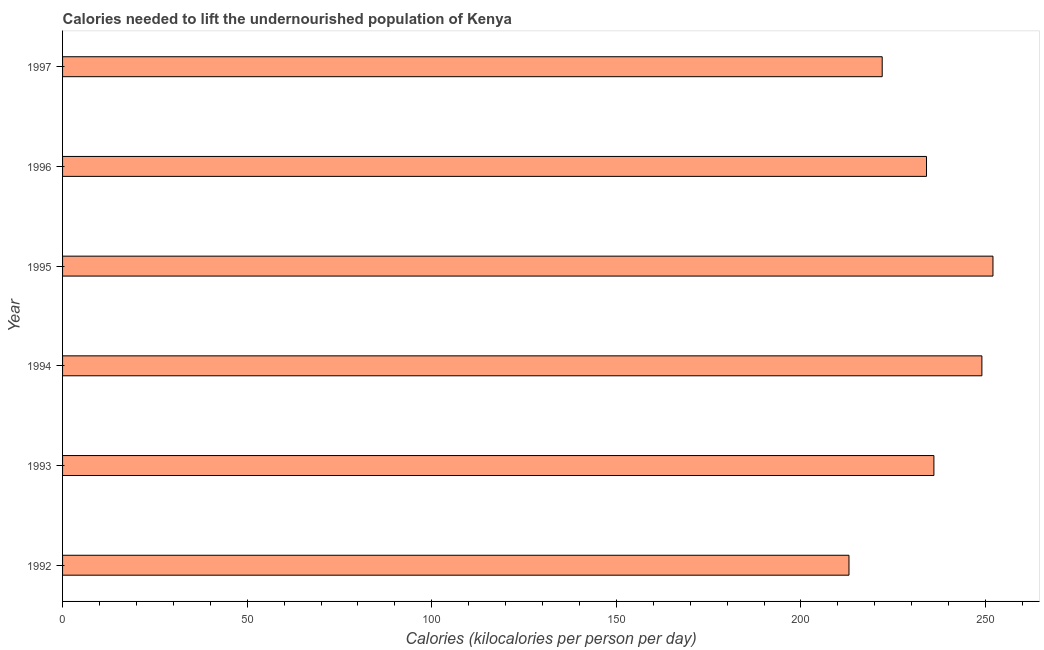Does the graph contain grids?
Provide a succinct answer. No. What is the title of the graph?
Keep it short and to the point. Calories needed to lift the undernourished population of Kenya. What is the label or title of the X-axis?
Keep it short and to the point. Calories (kilocalories per person per day). What is the depth of food deficit in 1996?
Your response must be concise. 234. Across all years, what is the maximum depth of food deficit?
Provide a short and direct response. 252. Across all years, what is the minimum depth of food deficit?
Your response must be concise. 213. In which year was the depth of food deficit minimum?
Make the answer very short. 1992. What is the sum of the depth of food deficit?
Your answer should be compact. 1406. What is the difference between the depth of food deficit in 1996 and 1997?
Provide a short and direct response. 12. What is the average depth of food deficit per year?
Your answer should be compact. 234. What is the median depth of food deficit?
Keep it short and to the point. 235. In how many years, is the depth of food deficit greater than 150 kilocalories?
Offer a terse response. 6. What is the ratio of the depth of food deficit in 1993 to that in 1994?
Your response must be concise. 0.95. What is the difference between the highest and the second highest depth of food deficit?
Make the answer very short. 3. Is the sum of the depth of food deficit in 1994 and 1997 greater than the maximum depth of food deficit across all years?
Offer a terse response. Yes. In how many years, is the depth of food deficit greater than the average depth of food deficit taken over all years?
Your response must be concise. 3. Are all the bars in the graph horizontal?
Keep it short and to the point. Yes. Are the values on the major ticks of X-axis written in scientific E-notation?
Make the answer very short. No. What is the Calories (kilocalories per person per day) of 1992?
Give a very brief answer. 213. What is the Calories (kilocalories per person per day) in 1993?
Make the answer very short. 236. What is the Calories (kilocalories per person per day) in 1994?
Ensure brevity in your answer.  249. What is the Calories (kilocalories per person per day) of 1995?
Keep it short and to the point. 252. What is the Calories (kilocalories per person per day) in 1996?
Keep it short and to the point. 234. What is the Calories (kilocalories per person per day) in 1997?
Give a very brief answer. 222. What is the difference between the Calories (kilocalories per person per day) in 1992 and 1993?
Make the answer very short. -23. What is the difference between the Calories (kilocalories per person per day) in 1992 and 1994?
Make the answer very short. -36. What is the difference between the Calories (kilocalories per person per day) in 1992 and 1995?
Offer a very short reply. -39. What is the difference between the Calories (kilocalories per person per day) in 1992 and 1996?
Provide a succinct answer. -21. What is the difference between the Calories (kilocalories per person per day) in 1993 and 1995?
Offer a very short reply. -16. What is the difference between the Calories (kilocalories per person per day) in 1993 and 1996?
Give a very brief answer. 2. What is the difference between the Calories (kilocalories per person per day) in 1993 and 1997?
Provide a succinct answer. 14. What is the difference between the Calories (kilocalories per person per day) in 1994 and 1995?
Your answer should be compact. -3. What is the difference between the Calories (kilocalories per person per day) in 1994 and 1997?
Your answer should be compact. 27. What is the difference between the Calories (kilocalories per person per day) in 1995 and 1997?
Offer a very short reply. 30. What is the ratio of the Calories (kilocalories per person per day) in 1992 to that in 1993?
Your response must be concise. 0.9. What is the ratio of the Calories (kilocalories per person per day) in 1992 to that in 1994?
Keep it short and to the point. 0.85. What is the ratio of the Calories (kilocalories per person per day) in 1992 to that in 1995?
Ensure brevity in your answer.  0.84. What is the ratio of the Calories (kilocalories per person per day) in 1992 to that in 1996?
Ensure brevity in your answer.  0.91. What is the ratio of the Calories (kilocalories per person per day) in 1993 to that in 1994?
Make the answer very short. 0.95. What is the ratio of the Calories (kilocalories per person per day) in 1993 to that in 1995?
Provide a succinct answer. 0.94. What is the ratio of the Calories (kilocalories per person per day) in 1993 to that in 1997?
Provide a succinct answer. 1.06. What is the ratio of the Calories (kilocalories per person per day) in 1994 to that in 1995?
Provide a succinct answer. 0.99. What is the ratio of the Calories (kilocalories per person per day) in 1994 to that in 1996?
Give a very brief answer. 1.06. What is the ratio of the Calories (kilocalories per person per day) in 1994 to that in 1997?
Your answer should be compact. 1.12. What is the ratio of the Calories (kilocalories per person per day) in 1995 to that in 1996?
Provide a succinct answer. 1.08. What is the ratio of the Calories (kilocalories per person per day) in 1995 to that in 1997?
Your answer should be very brief. 1.14. What is the ratio of the Calories (kilocalories per person per day) in 1996 to that in 1997?
Provide a succinct answer. 1.05. 